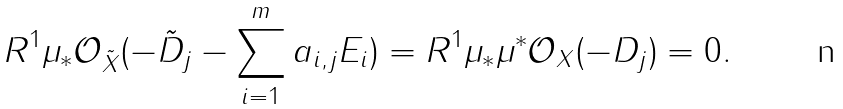Convert formula to latex. <formula><loc_0><loc_0><loc_500><loc_500>R ^ { 1 } \mu _ { * } \mathcal { O } _ { \tilde { X } } ( - \tilde { D } _ { j } - \sum _ { i = 1 } ^ { m } a _ { i , j } E _ { i } ) = R ^ { 1 } \mu _ { * } \mu ^ { * } \mathcal { O } _ { X } ( - D _ { j } ) = 0 .</formula> 